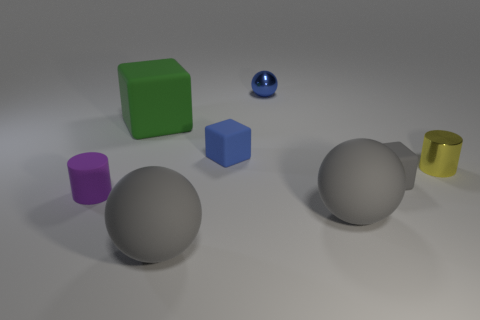What number of objects are either metal spheres behind the green thing or big gray balls that are on the left side of the tiny metal sphere?
Keep it short and to the point. 2. There is a blue rubber object that is the same size as the gray rubber cube; what is its shape?
Provide a succinct answer. Cube. The purple thing that is the same material as the small gray thing is what size?
Ensure brevity in your answer.  Small. Is the shape of the large green matte object the same as the blue metal object?
Your response must be concise. No. There is a shiny ball that is the same size as the purple rubber cylinder; what is its color?
Your answer should be very brief. Blue. What size is the other matte object that is the same shape as the small yellow object?
Offer a very short reply. Small. The large thing right of the tiny ball has what shape?
Provide a succinct answer. Sphere. Is the shape of the purple rubber thing the same as the small shiny thing that is to the left of the small gray rubber block?
Ensure brevity in your answer.  No. Is the number of balls that are behind the blue matte block the same as the number of green matte blocks that are behind the small yellow object?
Make the answer very short. Yes. What shape is the tiny thing that is the same color as the metallic sphere?
Provide a short and direct response. Cube. 